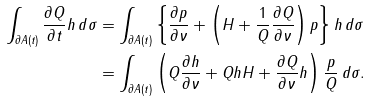Convert formula to latex. <formula><loc_0><loc_0><loc_500><loc_500>\int _ { \partial A ( t ) } \frac { \partial Q } { \partial t } h \, d \sigma & = \int _ { \partial A ( t ) } \left \{ \frac { \partial p } { \partial \nu } + \left ( H + \frac { 1 } { Q } \frac { \partial Q } { \partial \nu } \right ) p \right \} h \, d \sigma \\ & = \int _ { \partial A ( t ) } \left ( Q \frac { \partial h } { \partial \nu } + Q h H + \frac { \partial Q } { \partial \nu } h \right ) \frac { p } { Q } \, d \sigma .</formula> 